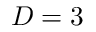Convert formula to latex. <formula><loc_0><loc_0><loc_500><loc_500>D = 3</formula> 